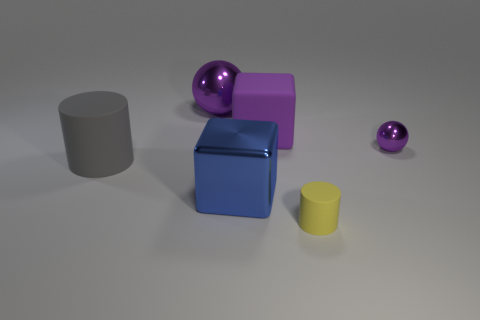Is the large blue metallic object the same shape as the small purple thing?
Offer a terse response. No. The metal object that is on the right side of the rubber cylinder right of the large matte cylinder is what color?
Ensure brevity in your answer.  Purple. The shiny block that is the same size as the gray matte cylinder is what color?
Your answer should be very brief. Blue. What number of metallic things are yellow things or large purple spheres?
Offer a terse response. 1. There is a matte thing that is in front of the large gray rubber cylinder; how many gray rubber cylinders are to the right of it?
Your answer should be compact. 0. The rubber thing that is the same color as the tiny shiny object is what size?
Make the answer very short. Large. What number of things are big gray metallic cubes or purple metallic things behind the tiny purple sphere?
Your answer should be very brief. 1. Are there any tiny objects made of the same material as the large cylinder?
Make the answer very short. Yes. What number of cylinders are both to the left of the large purple shiny thing and in front of the large cylinder?
Give a very brief answer. 0. What is the material of the block that is behind the big blue block?
Your answer should be compact. Rubber. 